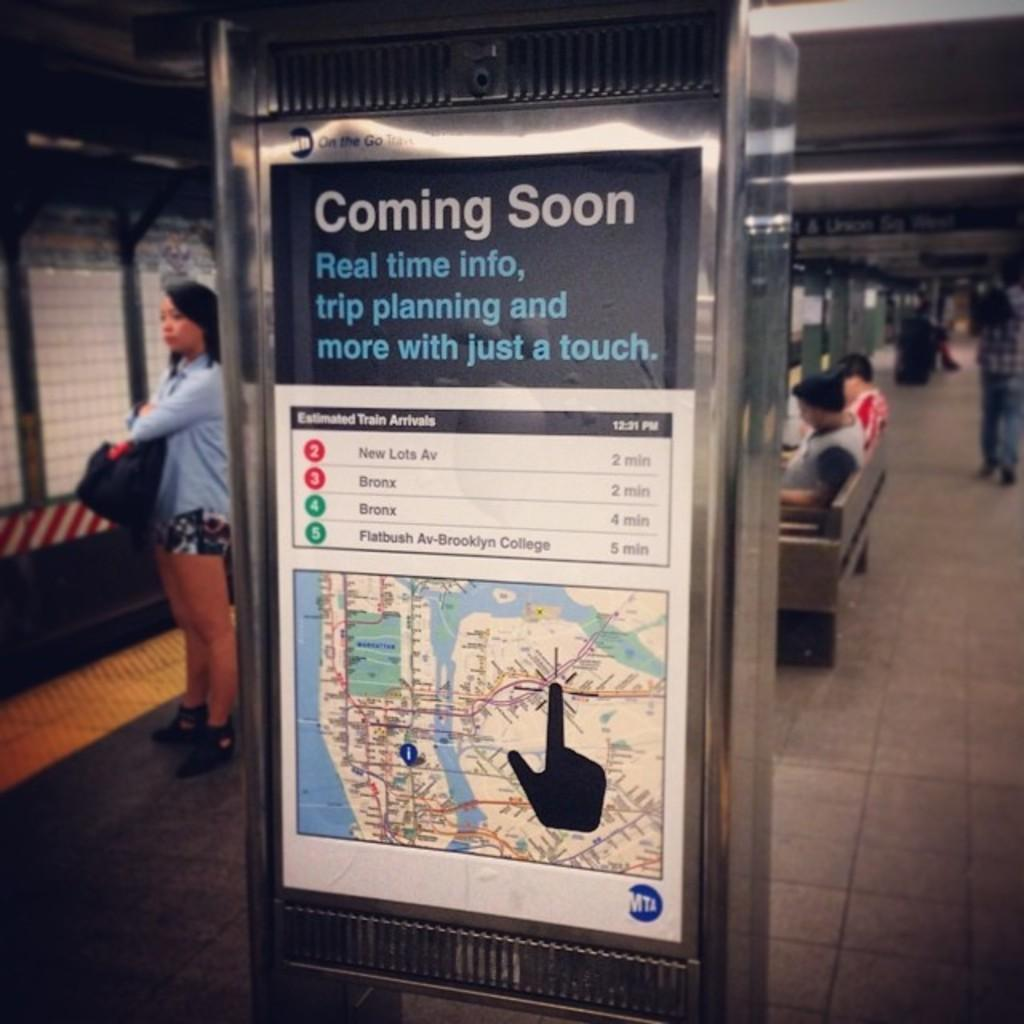<image>
Offer a succinct explanation of the picture presented. A sign at a subway station showing an app providing real time nfo and trip planning is coming soon. 